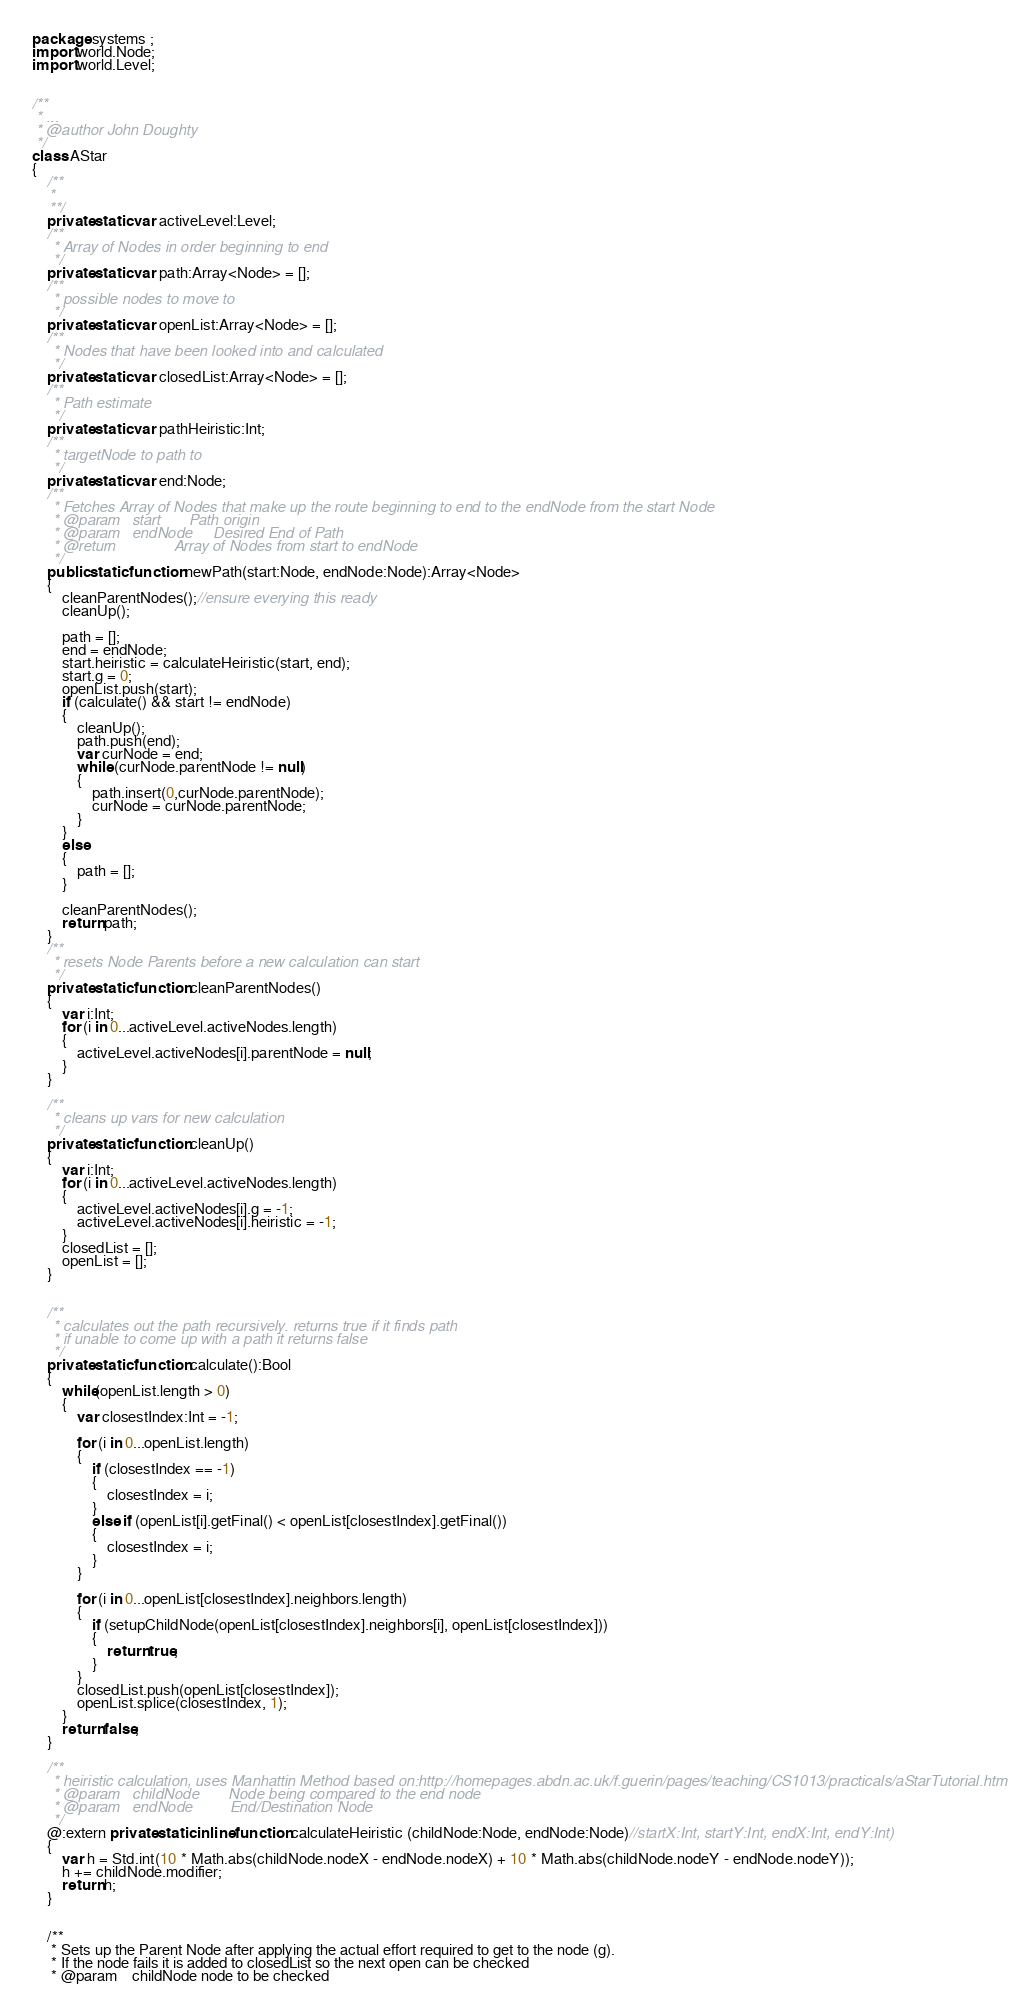<code> <loc_0><loc_0><loc_500><loc_500><_Haxe_>package systems ;
import world.Node;
import world.Level;


/**
 * ...
 * @author John Doughty
 */
class AStar
{
	/**
	* 
	**/
	private static var activeLevel:Level;
	/**
	 * Array of Nodes in order beginning to end
	 */
	private static var path:Array<Node> = [];
	/**
	 * possible nodes to move to
	 */
	private static var openList:Array<Node> = [];
	/**
	 * Nodes that have been looked into and calculated
	 */
	private static var closedList:Array<Node> = [];
	/**
	 * Path estimate
	 */
	private static var pathHeiristic:Int;
	/**
	 * targetNode to path to
	 */
	private static var end:Node;
	/**
	 * Fetches Array of Nodes that make up the route beginning to end to the endNode from the start Node
	 * @param	start 		Path origin
	 * @param	endNode		Desired End of Path
	 * @return				Array of Nodes from start to endNode
	 */
	public static function newPath(start:Node, endNode:Node):Array<Node>
	{
		cleanParentNodes();//ensure everying this ready
		cleanUp();
		
		path = [];
		end = endNode;
		start.heiristic = calculateHeiristic(start, end);
		start.g = 0;
		openList.push(start);
		if (calculate() && start != endNode)
		{
			cleanUp();
			path.push(end);
			var curNode = end;
			while (curNode.parentNode != null)
			{
				path.insert(0,curNode.parentNode);
				curNode = curNode.parentNode;
			}
		}
		else
		{
			path = [];
		}
		
		cleanParentNodes();
		return path;
	}
	/**
	 * resets Node Parents before a new calculation can start
	 */
	private static function cleanParentNodes()
	{
		var i:Int;
		for (i in 0...activeLevel.activeNodes.length)
		{
			activeLevel.activeNodes[i].parentNode = null;
		}
	}
	
	/**
	 * cleans up vars for new calculation
	 */
	private static function cleanUp()
	{
		var i:Int;
		for (i in 0...activeLevel.activeNodes.length)
		{
			activeLevel.activeNodes[i].g = -1;
			activeLevel.activeNodes[i].heiristic = -1;
		}
		closedList = [];
		openList = [];
	}
	

	/**
	 * calculates out the path recursively. returns true if it finds path
	 * if unable to come up with a path it returns false
	 */
	private static function calculate():Bool
	{
		while(openList.length > 0)
		{
			var closestIndex:Int = -1;

			for (i in 0...openList.length) 
			{
				if (closestIndex == -1) 
				{
					closestIndex = i;
				} 
				else if (openList[i].getFinal() < openList[closestIndex].getFinal()) 
				{
					closestIndex = i;
				}
			}

			for (i in 0...openList[closestIndex].neighbors.length) 
			{
				if (setupChildNode(openList[closestIndex].neighbors[i], openList[closestIndex]))
				{
					return true;
				}
			}
			closedList.push(openList[closestIndex]);
			openList.splice(closestIndex, 1);
		}
		return false;
	}
	
	/**
	 * heiristic calculation, uses Manhattin Method based on:http://homepages.abdn.ac.uk/f.guerin/pages/teaching/CS1013/practicals/aStarTutorial.htm
	 * @param	childNode		Node being compared to the end node
	 * @param	endNode			End/Destination Node
	 */
	@:extern private static inline function calculateHeiristic (childNode:Node, endNode:Node)//startX:Int, startY:Int, endX:Int, endY:Int) 
	{
        var h = Std.int(10 * Math.abs(childNode.nodeX - endNode.nodeX) + 10 * Math.abs(childNode.nodeY - endNode.nodeY));
		h += childNode.modifier;
        return h;
    }
	
	
	/**
	 * Sets up the Parent Node after applying the actual effort required to get to the node (g). 
	 * If the node fails it is added to closedList so the next open can be checked
	 * @param	childNode node to be checked</code> 